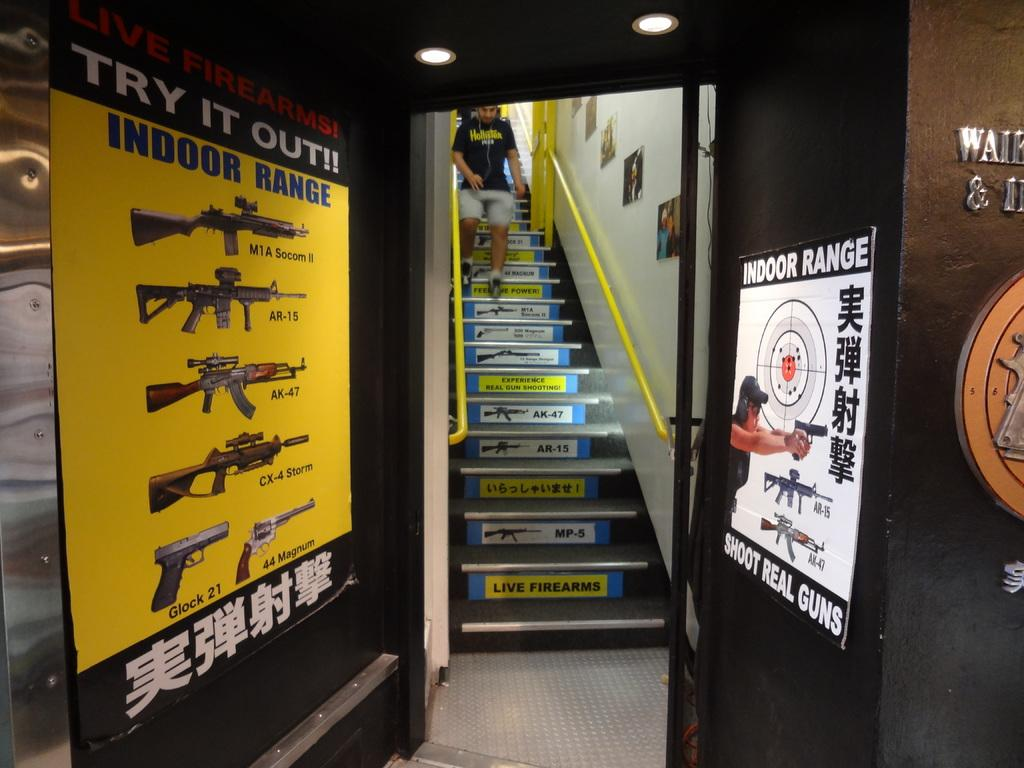<image>
Write a terse but informative summary of the picture. A open door leading to a stairway with signs on both sides of the doorway advertising an indoor range. 